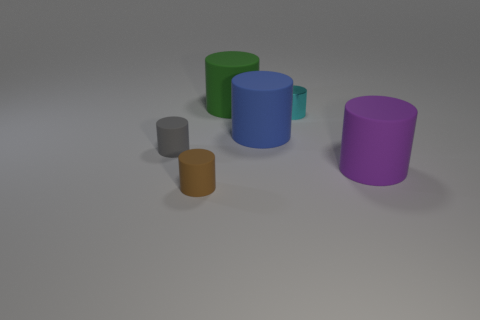What number of large things are both left of the metallic object and to the right of the small cyan metal cylinder?
Your answer should be compact. 0. What number of other objects are there of the same material as the small cyan object?
Your answer should be very brief. 0. Is the material of the big thing behind the small metal thing the same as the big blue cylinder?
Keep it short and to the point. Yes. There is a matte cylinder on the left side of the tiny cylinder in front of the large cylinder in front of the blue rubber cylinder; how big is it?
Your response must be concise. Small. How many other objects are there of the same color as the shiny cylinder?
Your response must be concise. 0. What is the shape of the purple matte object that is the same size as the blue rubber thing?
Offer a terse response. Cylinder. What is the size of the thing that is right of the cyan object?
Offer a very short reply. Large. What material is the small cylinder that is on the right side of the big green rubber object that is behind the cylinder right of the cyan shiny thing?
Your answer should be compact. Metal. Is there a matte object that has the same size as the blue cylinder?
Provide a short and direct response. Yes. There is a cyan cylinder that is the same size as the gray matte cylinder; what is its material?
Your answer should be very brief. Metal. 